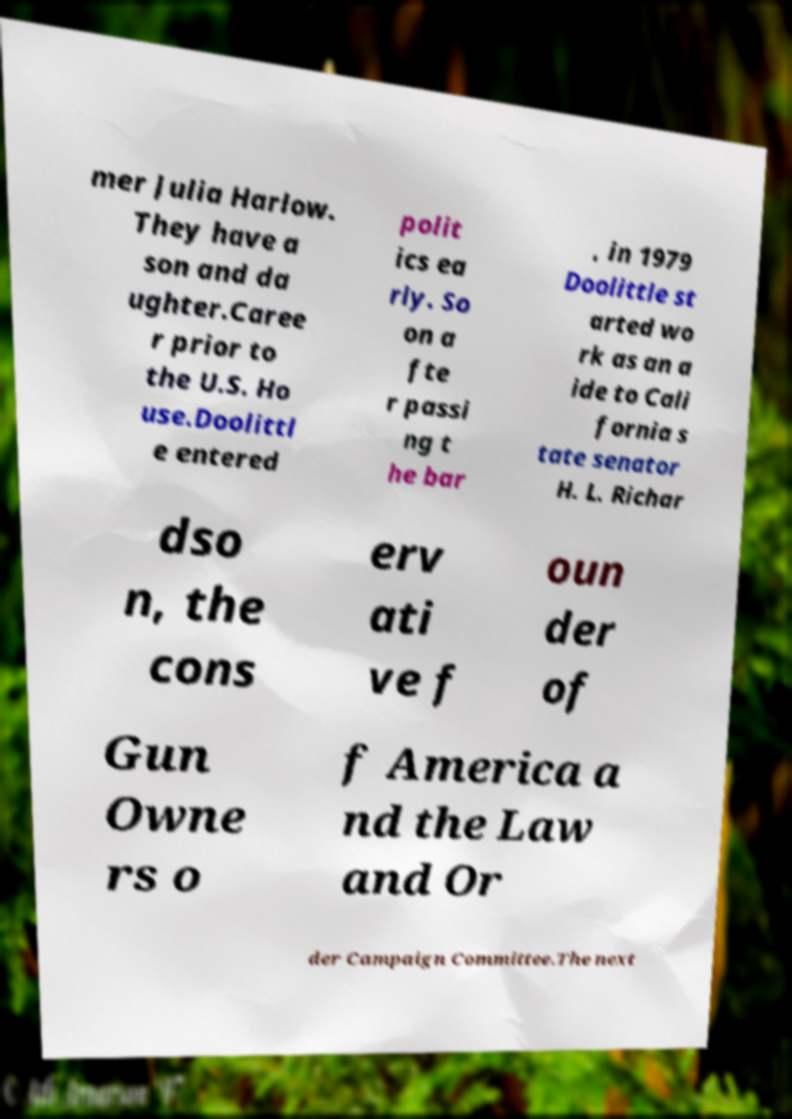Please read and relay the text visible in this image. What does it say? mer Julia Harlow. They have a son and da ughter.Caree r prior to the U.S. Ho use.Doolittl e entered polit ics ea rly. So on a fte r passi ng t he bar , in 1979 Doolittle st arted wo rk as an a ide to Cali fornia s tate senator H. L. Richar dso n, the cons erv ati ve f oun der of Gun Owne rs o f America a nd the Law and Or der Campaign Committee.The next 